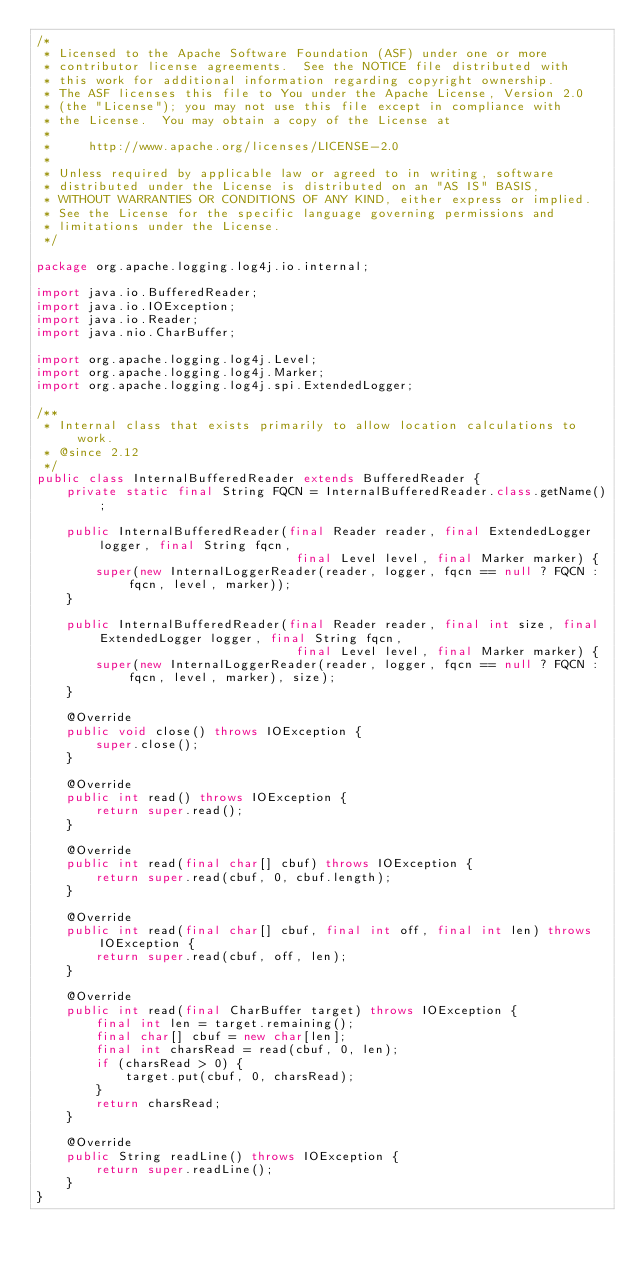Convert code to text. <code><loc_0><loc_0><loc_500><loc_500><_Java_>/*
 * Licensed to the Apache Software Foundation (ASF) under one or more
 * contributor license agreements.  See the NOTICE file distributed with
 * this work for additional information regarding copyright ownership.
 * The ASF licenses this file to You under the Apache License, Version 2.0
 * (the "License"); you may not use this file except in compliance with
 * the License.  You may obtain a copy of the License at
 *
 *     http://www.apache.org/licenses/LICENSE-2.0
 *
 * Unless required by applicable law or agreed to in writing, software
 * distributed under the License is distributed on an "AS IS" BASIS,
 * WITHOUT WARRANTIES OR CONDITIONS OF ANY KIND, either express or implied.
 * See the License for the specific language governing permissions and
 * limitations under the License.
 */

package org.apache.logging.log4j.io.internal;

import java.io.BufferedReader;
import java.io.IOException;
import java.io.Reader;
import java.nio.CharBuffer;

import org.apache.logging.log4j.Level;
import org.apache.logging.log4j.Marker;
import org.apache.logging.log4j.spi.ExtendedLogger;

/**
 * Internal class that exists primarily to allow location calculations to work.
 * @since 2.12
 */
public class InternalBufferedReader extends BufferedReader {
    private static final String FQCN = InternalBufferedReader.class.getName();

    public InternalBufferedReader(final Reader reader, final ExtendedLogger logger, final String fqcn,
                                   final Level level, final Marker marker) {
        super(new InternalLoggerReader(reader, logger, fqcn == null ? FQCN : fqcn, level, marker));
    }

    public InternalBufferedReader(final Reader reader, final int size, final ExtendedLogger logger, final String fqcn,
                                   final Level level, final Marker marker) {
        super(new InternalLoggerReader(reader, logger, fqcn == null ? FQCN : fqcn, level, marker), size);
    }

    @Override
    public void close() throws IOException {
        super.close();
    }

    @Override
    public int read() throws IOException {
        return super.read();
    }

    @Override
    public int read(final char[] cbuf) throws IOException {
        return super.read(cbuf, 0, cbuf.length);
    }

    @Override
    public int read(final char[] cbuf, final int off, final int len) throws IOException {
        return super.read(cbuf, off, len);
    }

    @Override
    public int read(final CharBuffer target) throws IOException {
        final int len = target.remaining();
        final char[] cbuf = new char[len];
        final int charsRead = read(cbuf, 0, len);
        if (charsRead > 0) {
            target.put(cbuf, 0, charsRead);
        }
        return charsRead;
    }

    @Override
    public String readLine() throws IOException {
        return super.readLine();
    }
}
</code> 